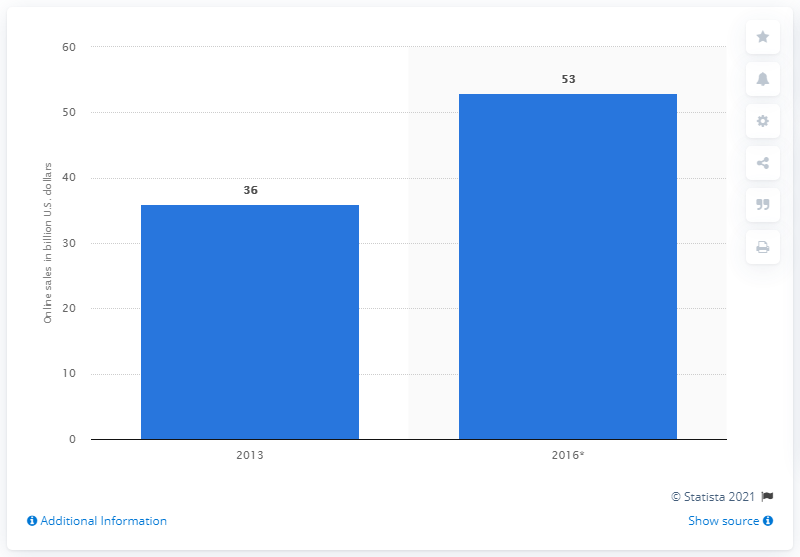Highlight a few significant elements in this photo. The increase in worldwide FMCG online shopping began in 2013. In 2016, the estimated value of global FMCG e-commerce sales was approximately $53 billion. 